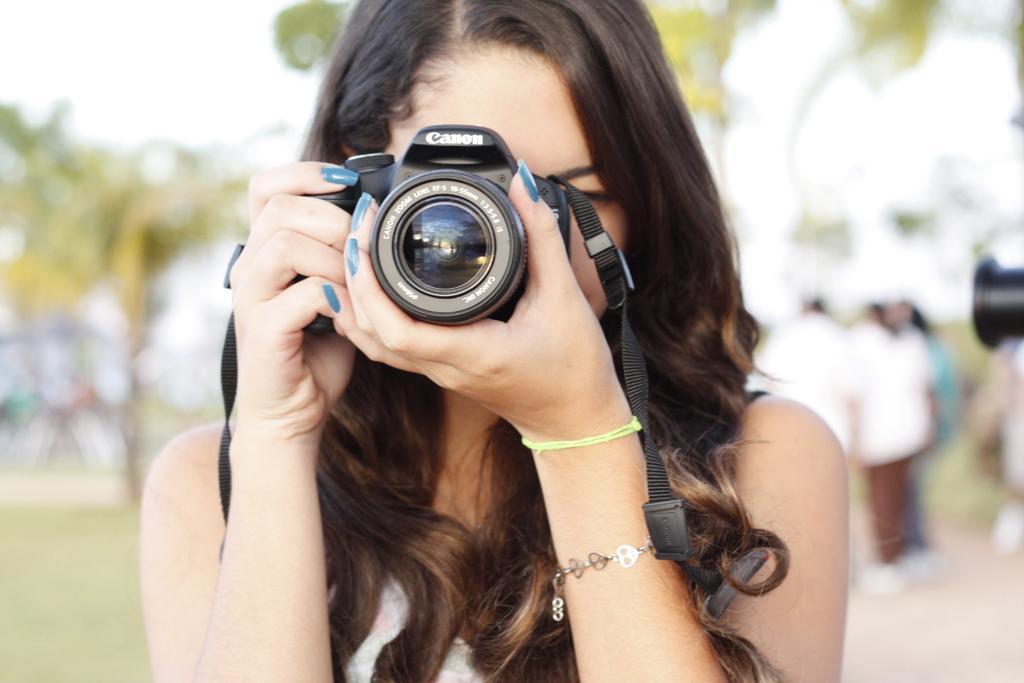Can you describe this image briefly? a person is standing , holding a canon camera in her hand. behind her there are other people standing at the right and there are trees at the back. the person at the front is wearing blue nail polish and a bracelet in her hand. 